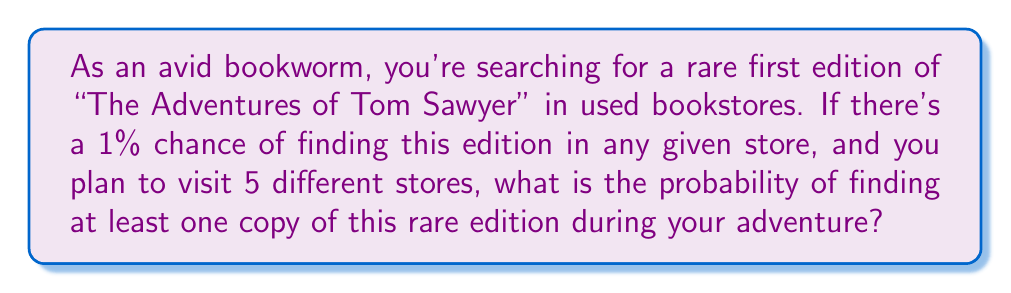Provide a solution to this math problem. Let's approach this step-by-step:

1) First, let's define our events:
   $A$ = finding the rare edition in a store
   $P(A) = 0.01$ (1% chance)

2) We want to find the probability of finding at least one copy in 5 stores. It's easier to calculate the probability of not finding any copies and then subtract that from 1.

3) The probability of not finding the book in one store is:
   $P(\text{not A}) = 1 - P(A) = 1 - 0.01 = 0.99$

4) For 5 independent stores, the probability of not finding the book in any of them is:
   $P(\text{not finding in 5 stores}) = (0.99)^5$

5) Now, we can calculate the probability of finding at least one copy:
   $P(\text{at least one}) = 1 - P(\text{none})$
   $= 1 - (0.99)^5$

6) Let's calculate this:
   $1 - (0.99)^5 = 1 - 0.9509775 = 0.0490225$

7) Converting to a percentage:
   $0.0490225 * 100 = 4.90225\%$

Therefore, the probability of finding at least one copy of the rare edition in 5 stores is approximately 4.90%.
Answer: $4.90\%$ 